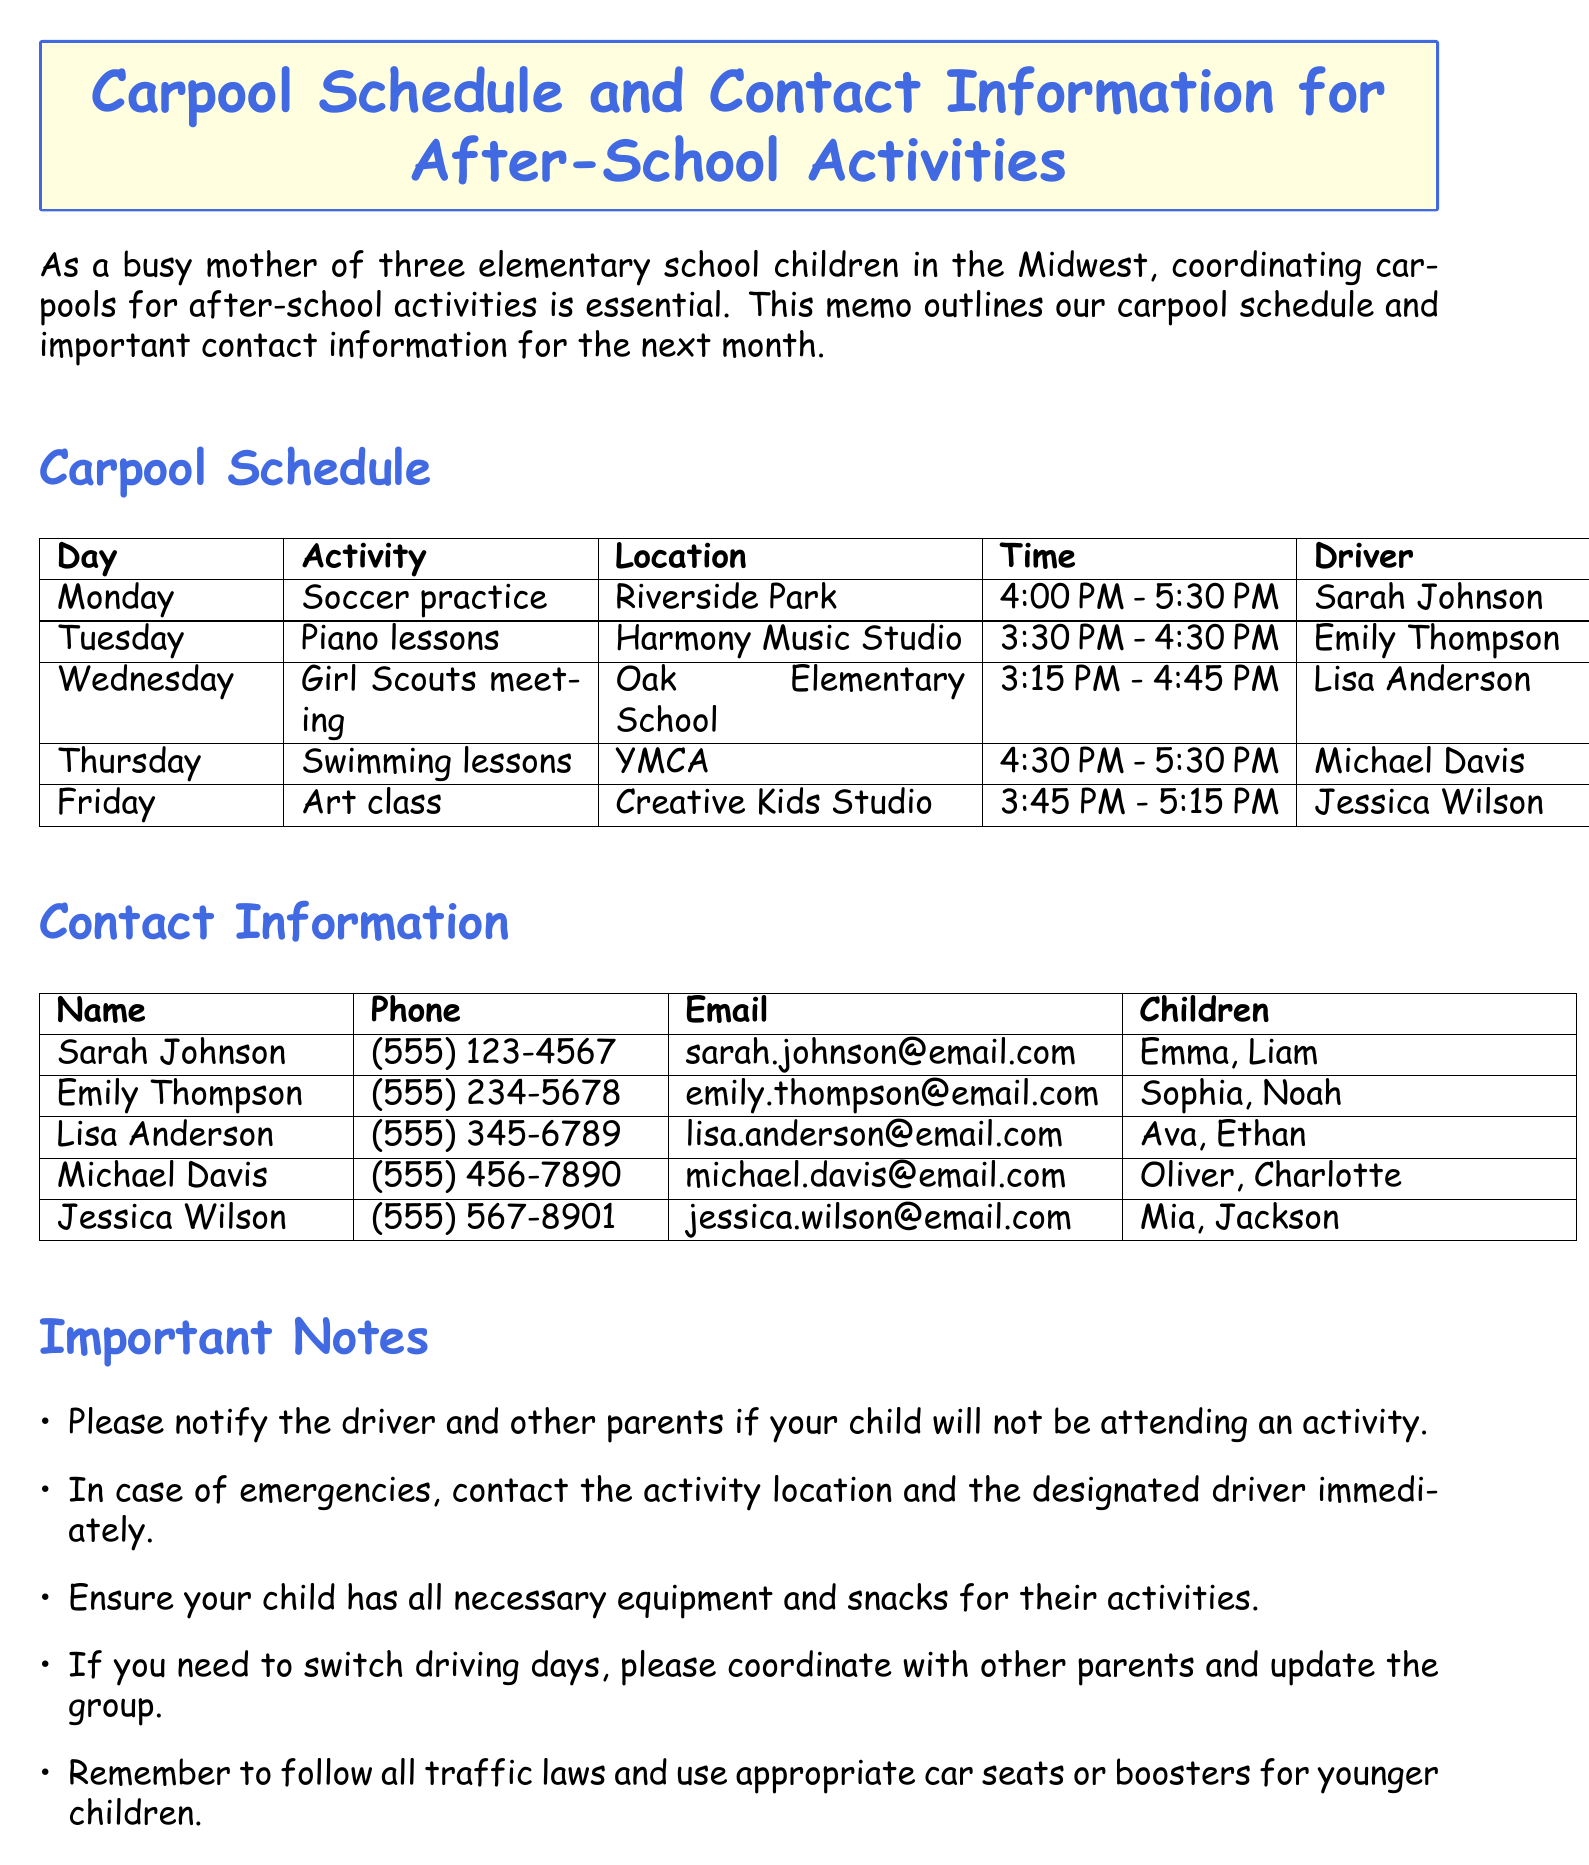What day is soccer practice scheduled? Soccer practice is scheduled on Monday as stated in the carpool schedule.
Answer: Monday Who is the driver for piano lessons? The memo specifies that Emily Thompson is the designated driver for piano lessons.
Answer: Emily Thompson What is the time for swimming lessons? The swimming lessons are scheduled from 4:30 PM to 5:30 PM according to the carpool schedule.
Answer: 4:30 PM - 5:30 PM Which location is specified for the Girl Scouts meeting? The Girl Scouts meeting is held at Oak Elementary School as mentioned in the carpool schedule.
Answer: Oak Elementary School How many children does Lisa Anderson have? The memo lists that Lisa Anderson has two children: Ava and Ethan.
Answer: 2 What should parents do if their child will not attend an activity? Parents need to notify the driver and other parents if their child will not be attending an activity.
Answer: Notify the driver and other parents When will the next rotation of the carpool schedule be discussed? The next rotation will be discussed at the upcoming PTA meeting on the 15th, as outlined in the document.
Answer: 15th What are parents advised to keep in the car due to unpredictable Midwest weather? Parents are advised to keep extra jackets or umbrellas in the car for weather considerations.
Answer: Extra jackets or umbrellas How many activities are listed in the carpool schedule? The carpool schedule lists five activities for the month.
Answer: 5 